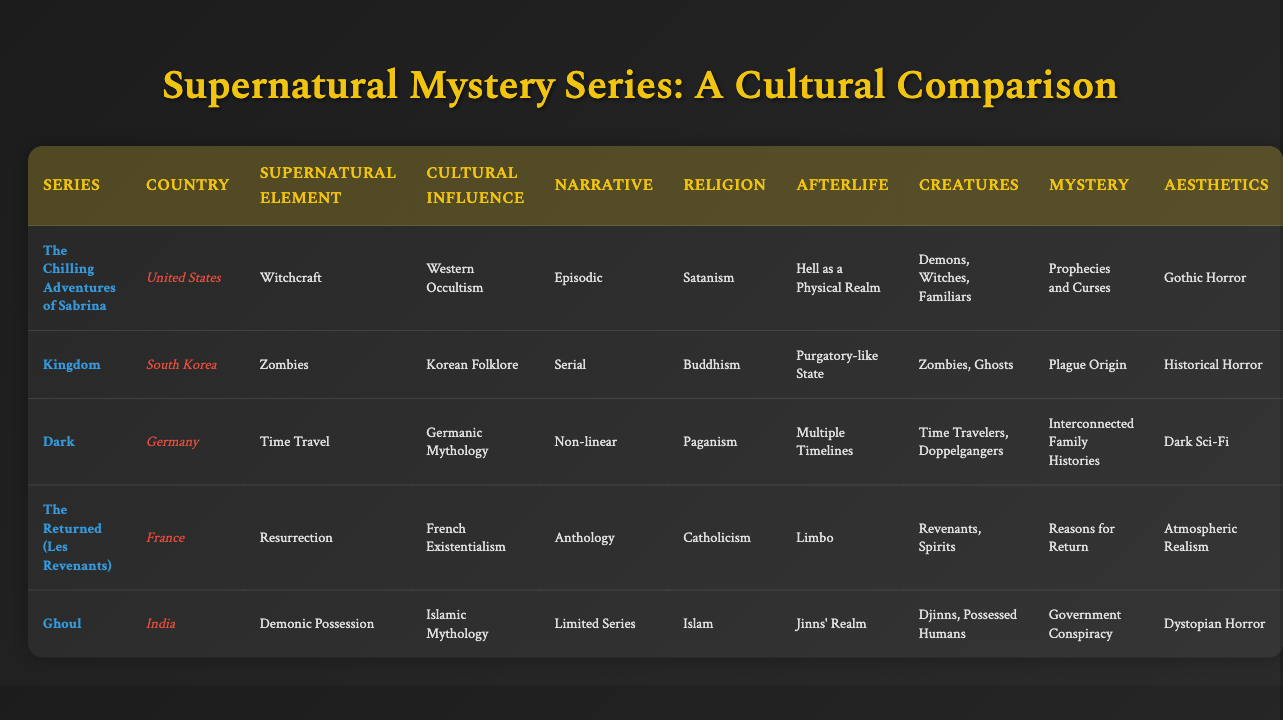What is the primary supernatural element in "Ghoul"? The table lists "Demonic Possession" as the primary supernatural element for the series "Ghoul" in the corresponding row.
Answer: Demonic Possession Which series is associated with Korean Folklore? The entry for "Kingdom" indicates that its cultural influence is based on Korean Folklore.
Answer: Kingdom How many series depict the afterlife as a physical realm? The table shows that only "The Chilling Adventures of Sabrina" has "Hell as a Physical Realm" listed under Afterlife Depiction. Therefore, there is one series with this depiction.
Answer: 1 Do any series have multiple timelines as part of their afterlife depiction? Looking at the Afterlife Depiction column, "Dark" shows "Multiple Timelines," confirming the presence of this concept in the series.
Answer: Yes Which series from the table employs a non-linear narrative structure? The table indicates that "Dark" utilizes a non-linear narrative structure, as clearly referenced in its corresponding column.
Answer: Dark How many series use zombies as a primary supernatural element? Only "Kingdom" features zombies as its primary supernatural element, making it one series.
Answer: 1 Is there a series with a mystery element related to government conspiracy? The entry for "Ghoul" states that its mystery element involves a government conspiracy, confirming the presence of this aspect in the series.
Answer: Yes Which two series have visual aesthetics categorized under horror? "The Chilling Adventures of Sabrina" and "Ghoul" are listed with Gothic Horror and Dystopian Horror aesthetics, respectively, thus encompassing these two series in the horror category.
Answer: 2 Which cultural influence is linked to the series "The Returned (Les Revenants)"? The table identifies "French Existentialism" as the cultural influence for "The Returned (Les Revenants)".
Answer: French Existentialism What is the average number of supernatural creatures depicted across these series? The series feature the following number of different supernatural creatures: "The Chilling Adventures of Sabrina" (3), "Kingdom" (2), "Dark" (3), "The Returned (Les Revenants)" (2), and "Ghoul" (2). Adding them gives 12, and dividing by 5 for the average results in 2.4.
Answer: 2.4 